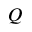Convert formula to latex. <formula><loc_0><loc_0><loc_500><loc_500>Q</formula> 